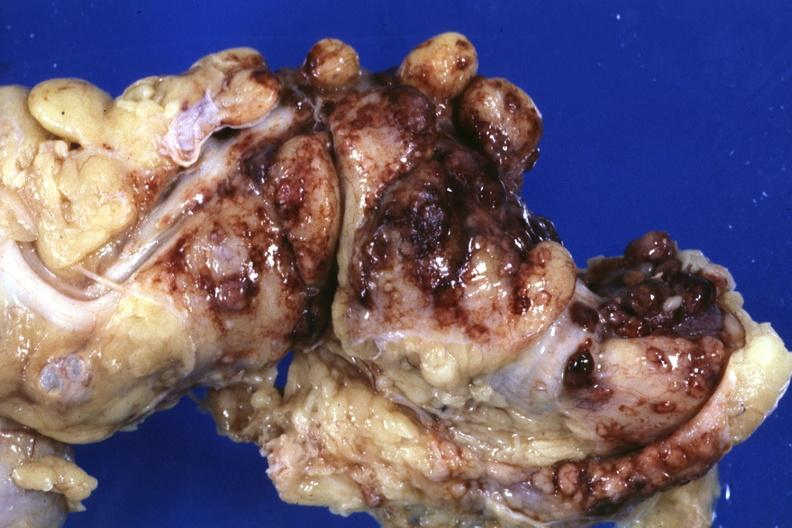where is this area in the body?
Answer the question using a single word or phrase. Abdomen 